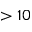<formula> <loc_0><loc_0><loc_500><loc_500>> 1 0</formula> 